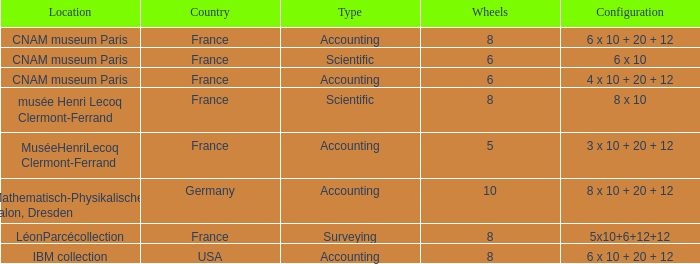What is the configuration for the country France, with accounting as the type, and wheels greater than 6? 6 x 10 + 20 + 12. 